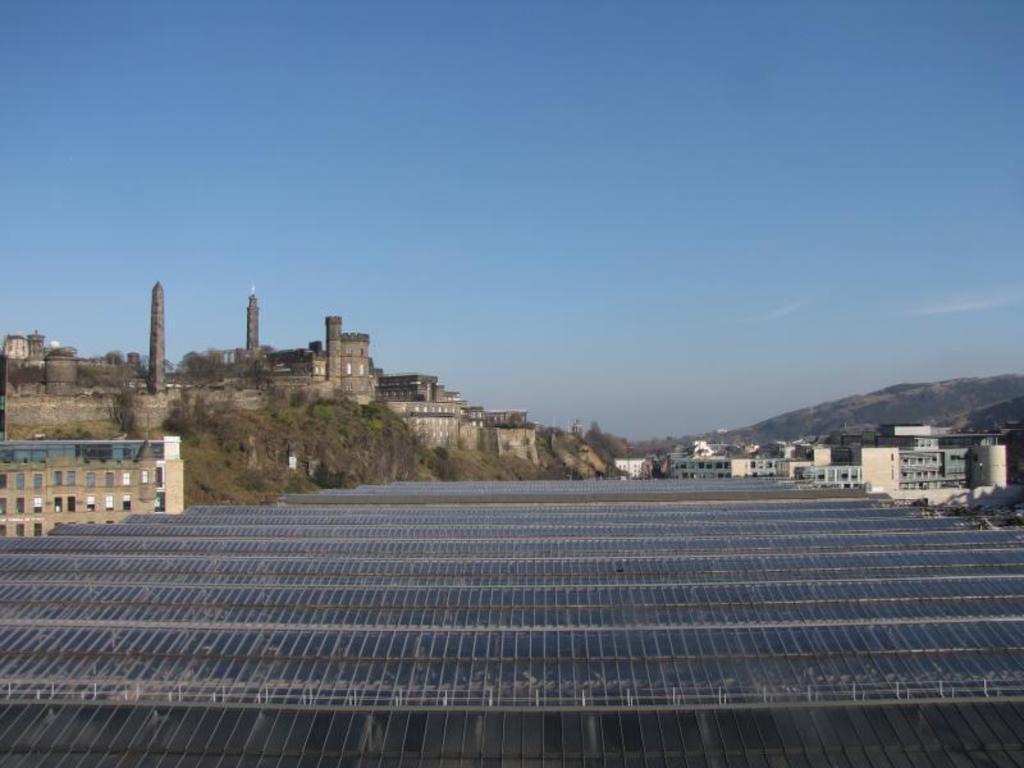Can you describe this image briefly? In this image we can see the roof, buildings, hills and the blue sky in the background. 